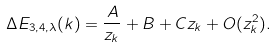<formula> <loc_0><loc_0><loc_500><loc_500>\Delta E _ { 3 , 4 , \lambda } ( k ) = \frac { A } { z _ { k } } + B + C z _ { k } + O ( z ^ { 2 } _ { k } ) .</formula> 